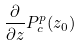Convert formula to latex. <formula><loc_0><loc_0><loc_500><loc_500>\frac { \partial } { \partial z } P _ { c } ^ { p } ( z _ { 0 } )</formula> 